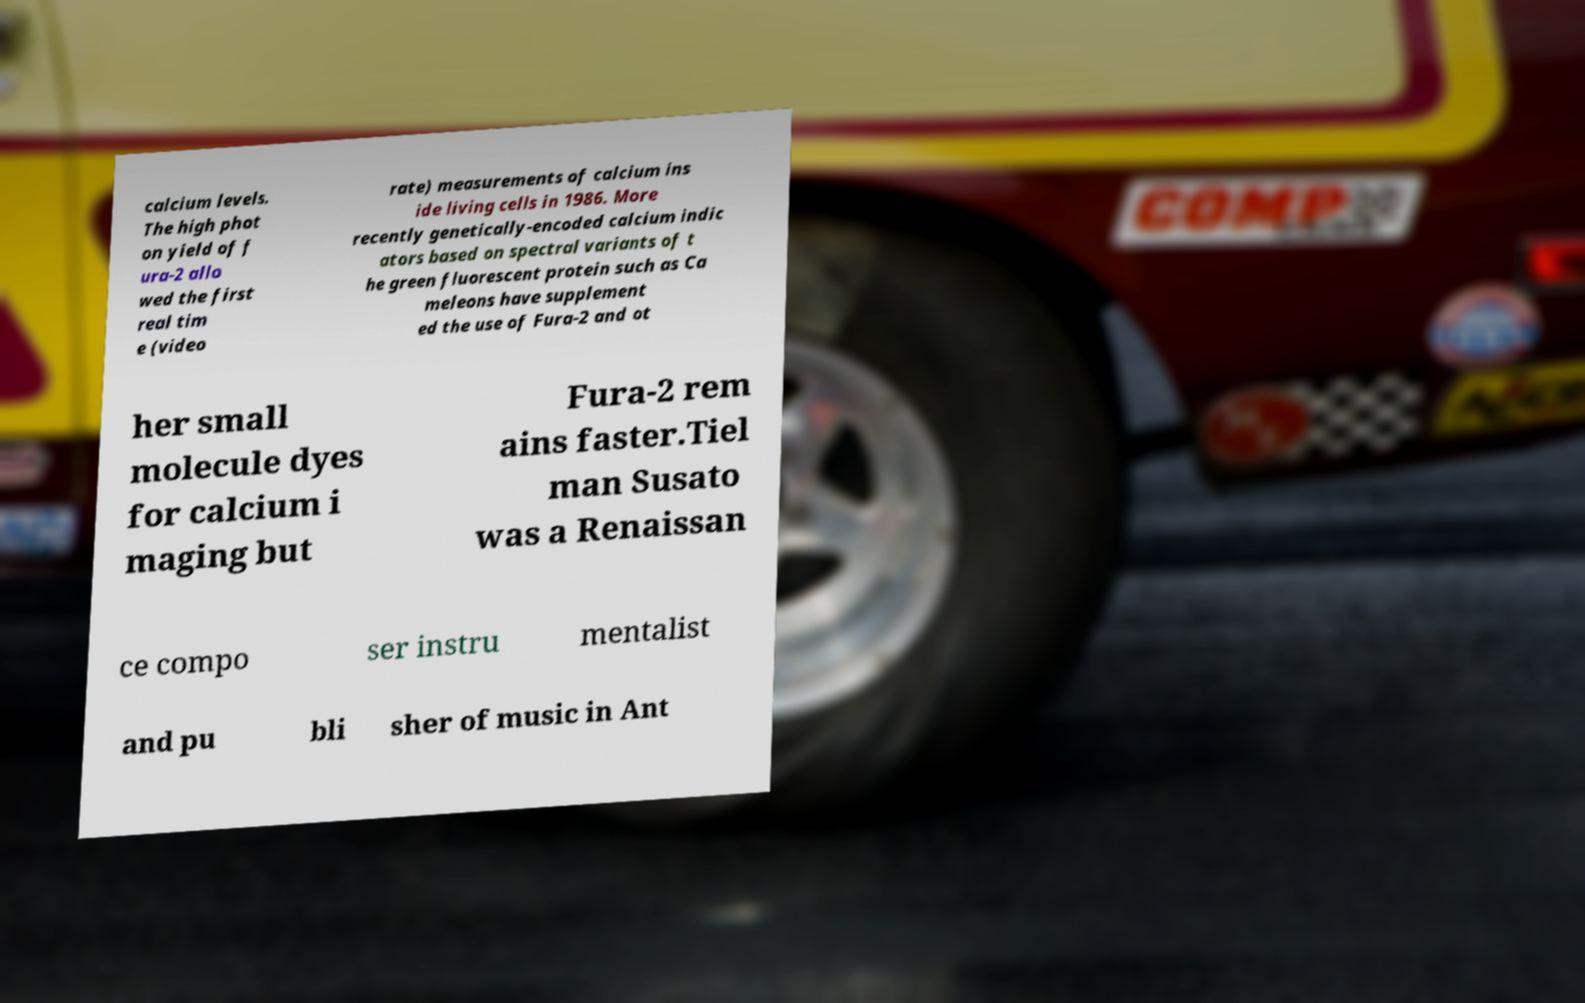There's text embedded in this image that I need extracted. Can you transcribe it verbatim? calcium levels. The high phot on yield of f ura-2 allo wed the first real tim e (video rate) measurements of calcium ins ide living cells in 1986. More recently genetically-encoded calcium indic ators based on spectral variants of t he green fluorescent protein such as Ca meleons have supplement ed the use of Fura-2 and ot her small molecule dyes for calcium i maging but Fura-2 rem ains faster.Tiel man Susato was a Renaissan ce compo ser instru mentalist and pu bli sher of music in Ant 